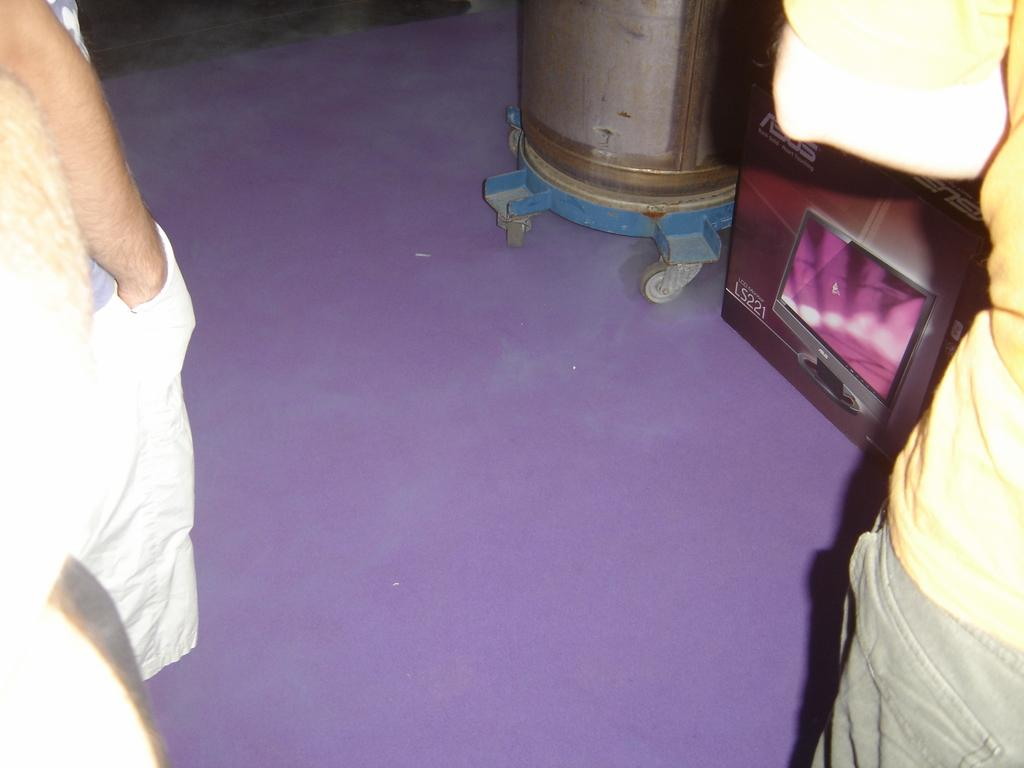What are the people in the image doing? The people in the image are standing on a path. What is located on the purple carpet in the image? There is a vessel and a box on the purple carpet. Can you describe the object visible in the background of the image? Unfortunately, the provided facts do not give enough information to describe the object in the background. What type of canvas is the cat using to paint in the image? There is no canvas or cat present in the image. What scientific experiment is being conducted on the purple carpet in the image? There is no scientific experiment or reference to science in the image. 